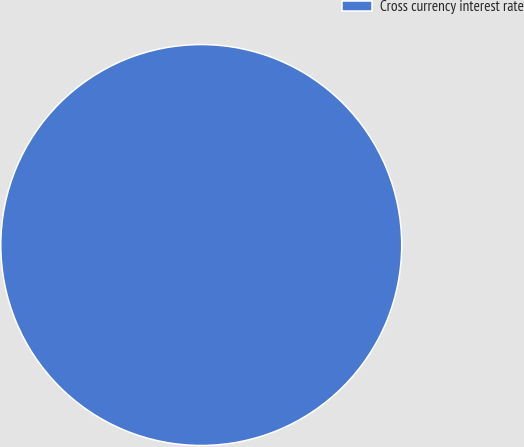<chart> <loc_0><loc_0><loc_500><loc_500><pie_chart><fcel>Cross currency interest rate<nl><fcel>100.0%<nl></chart> 